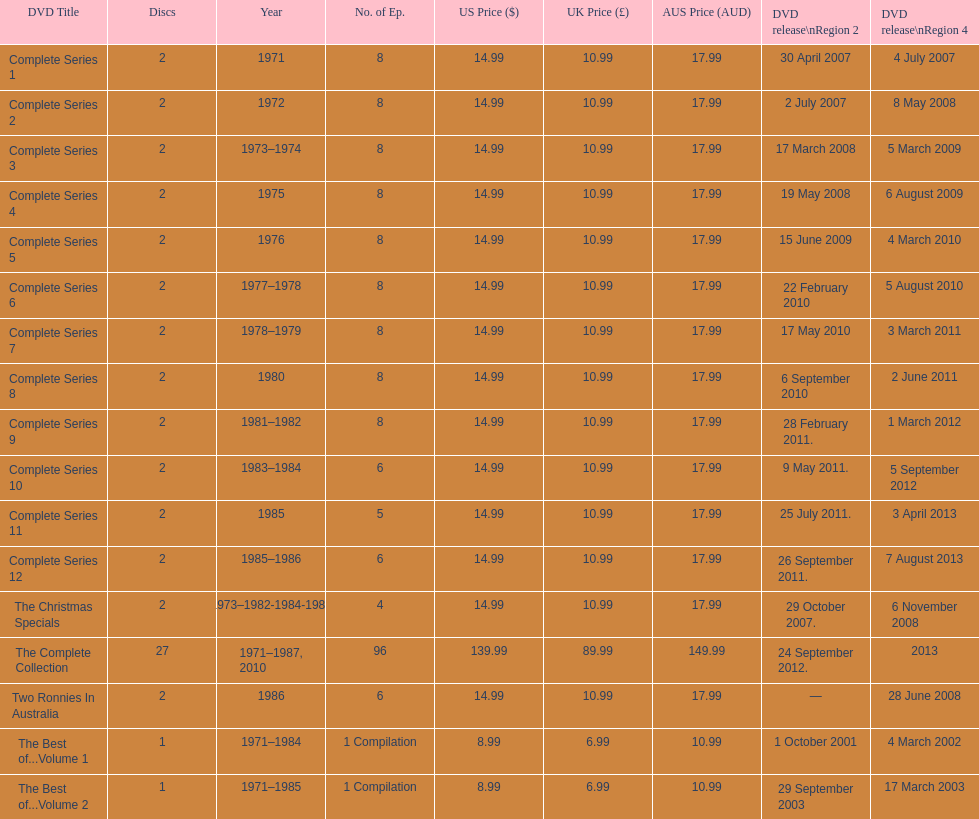How many "best of" volumes compile the top episodes of the television show "the two ronnies". 2. 